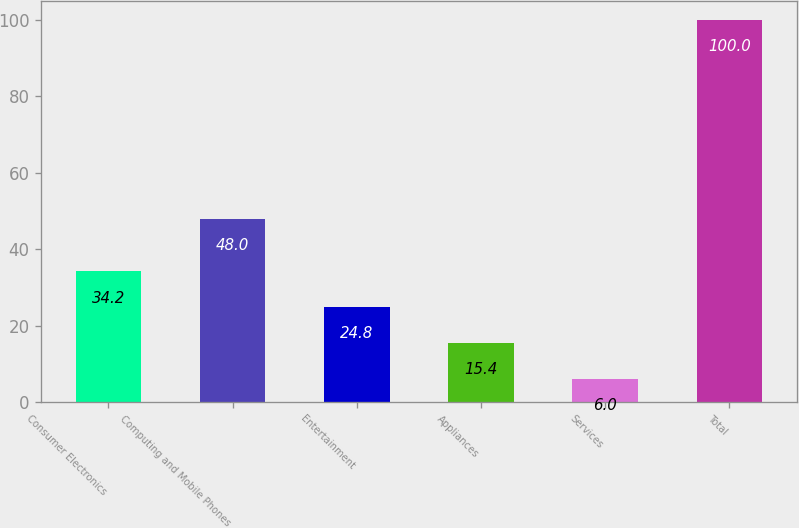Convert chart. <chart><loc_0><loc_0><loc_500><loc_500><bar_chart><fcel>Consumer Electronics<fcel>Computing and Mobile Phones<fcel>Entertainment<fcel>Appliances<fcel>Services<fcel>Total<nl><fcel>34.2<fcel>48<fcel>24.8<fcel>15.4<fcel>6<fcel>100<nl></chart> 